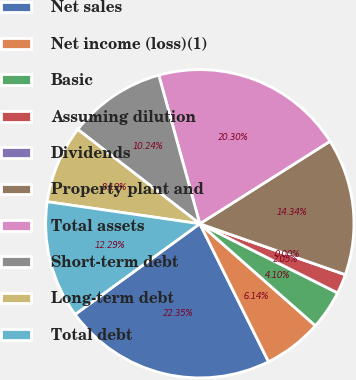Convert chart to OTSL. <chart><loc_0><loc_0><loc_500><loc_500><pie_chart><fcel>Net sales<fcel>Net income (loss)(1)<fcel>Basic<fcel>Assuming dilution<fcel>Dividends<fcel>Property plant and<fcel>Total assets<fcel>Short-term debt<fcel>Long-term debt<fcel>Total debt<nl><fcel>22.35%<fcel>6.14%<fcel>4.1%<fcel>2.05%<fcel>0.0%<fcel>14.34%<fcel>20.3%<fcel>10.24%<fcel>8.19%<fcel>12.29%<nl></chart> 